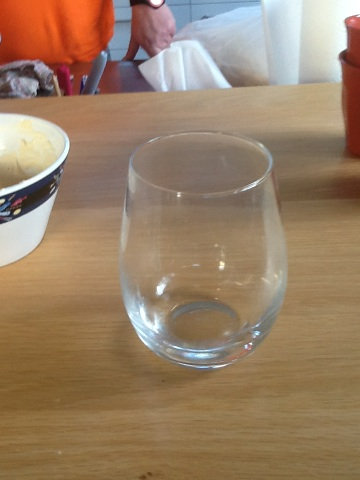What is the effect of the glass design on wine tasting? The design of this stemless wine glass affects how the wine heats up slightly faster from hand warmth, which can be an advantage when drinking more aromatic white or young red wines that benefit from a bit of warmth to enhance their flavors. 